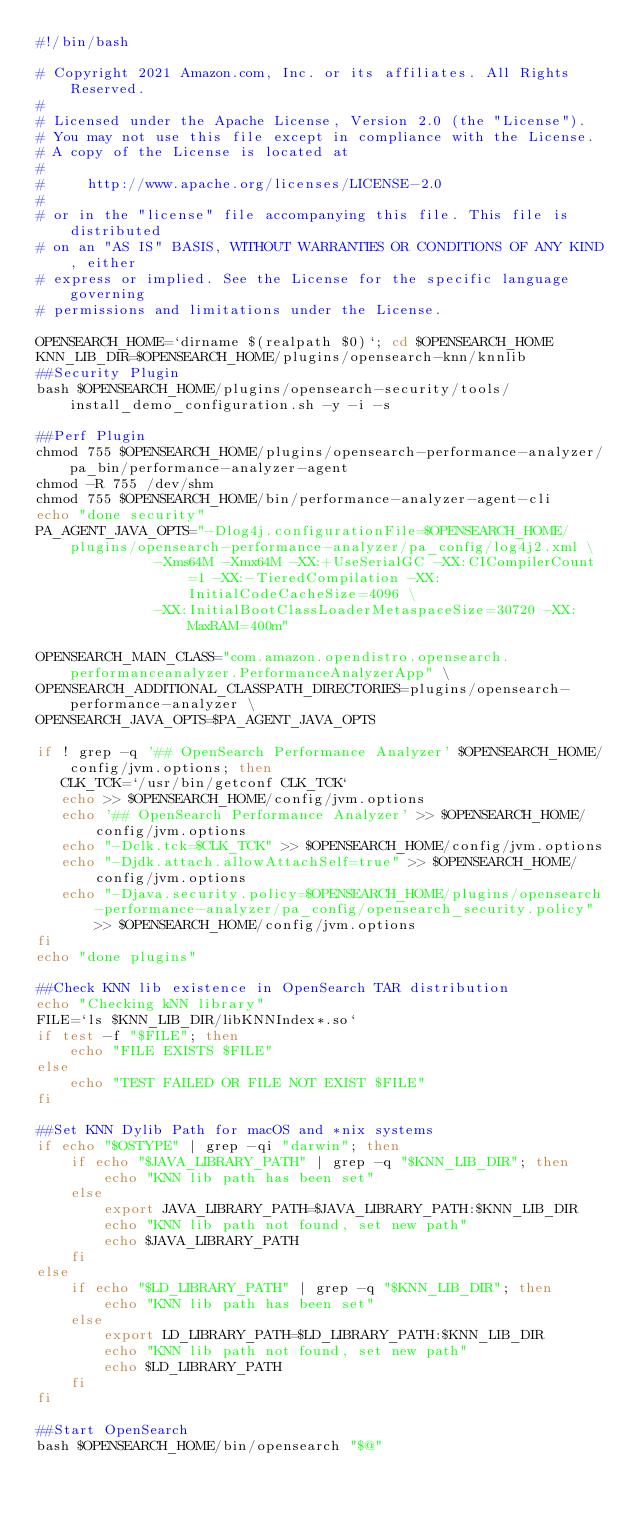<code> <loc_0><loc_0><loc_500><loc_500><_Bash_>#!/bin/bash

# Copyright 2021 Amazon.com, Inc. or its affiliates. All Rights Reserved.
#
# Licensed under the Apache License, Version 2.0 (the "License").
# You may not use this file except in compliance with the License.
# A copy of the License is located at
#
#     http://www.apache.org/licenses/LICENSE-2.0
#
# or in the "license" file accompanying this file. This file is distributed
# on an "AS IS" BASIS, WITHOUT WARRANTIES OR CONDITIONS OF ANY KIND, either
# express or implied. See the License for the specific language governing
# permissions and limitations under the License.

OPENSEARCH_HOME=`dirname $(realpath $0)`; cd $OPENSEARCH_HOME
KNN_LIB_DIR=$OPENSEARCH_HOME/plugins/opensearch-knn/knnlib
##Security Plugin
bash $OPENSEARCH_HOME/plugins/opensearch-security/tools/install_demo_configuration.sh -y -i -s

##Perf Plugin
chmod 755 $OPENSEARCH_HOME/plugins/opensearch-performance-analyzer/pa_bin/performance-analyzer-agent
chmod -R 755 /dev/shm
chmod 755 $OPENSEARCH_HOME/bin/performance-analyzer-agent-cli
echo "done security"
PA_AGENT_JAVA_OPTS="-Dlog4j.configurationFile=$OPENSEARCH_HOME/plugins/opensearch-performance-analyzer/pa_config/log4j2.xml \
              -Xms64M -Xmx64M -XX:+UseSerialGC -XX:CICompilerCount=1 -XX:-TieredCompilation -XX:InitialCodeCacheSize=4096 \
              -XX:InitialBootClassLoaderMetaspaceSize=30720 -XX:MaxRAM=400m"

OPENSEARCH_MAIN_CLASS="com.amazon.opendistro.opensearch.performanceanalyzer.PerformanceAnalyzerApp" \
OPENSEARCH_ADDITIONAL_CLASSPATH_DIRECTORIES=plugins/opensearch-performance-analyzer \
OPENSEARCH_JAVA_OPTS=$PA_AGENT_JAVA_OPTS

if ! grep -q '## OpenSearch Performance Analyzer' $OPENSEARCH_HOME/config/jvm.options; then
   CLK_TCK=`/usr/bin/getconf CLK_TCK`
   echo >> $OPENSEARCH_HOME/config/jvm.options
   echo '## OpenSearch Performance Analyzer' >> $OPENSEARCH_HOME/config/jvm.options
   echo "-Dclk.tck=$CLK_TCK" >> $OPENSEARCH_HOME/config/jvm.options
   echo "-Djdk.attach.allowAttachSelf=true" >> $OPENSEARCH_HOME/config/jvm.options
   echo "-Djava.security.policy=$OPENSEARCH_HOME/plugins/opensearch-performance-analyzer/pa_config/opensearch_security.policy" >> $OPENSEARCH_HOME/config/jvm.options
fi
echo "done plugins"

##Check KNN lib existence in OpenSearch TAR distribution
echo "Checking kNN library"
FILE=`ls $KNN_LIB_DIR/libKNNIndex*.so`
if test -f "$FILE"; then
    echo "FILE EXISTS $FILE"
else
    echo "TEST FAILED OR FILE NOT EXIST $FILE"
fi

##Set KNN Dylib Path for macOS and *nix systems
if echo "$OSTYPE" | grep -qi "darwin"; then
    if echo "$JAVA_LIBRARY_PATH" | grep -q "$KNN_LIB_DIR"; then
        echo "KNN lib path has been set"
    else
        export JAVA_LIBRARY_PATH=$JAVA_LIBRARY_PATH:$KNN_LIB_DIR
        echo "KNN lib path not found, set new path"
        echo $JAVA_LIBRARY_PATH
    fi
else
    if echo "$LD_LIBRARY_PATH" | grep -q "$KNN_LIB_DIR"; then
        echo "KNN lib path has been set"
    else
        export LD_LIBRARY_PATH=$LD_LIBRARY_PATH:$KNN_LIB_DIR
        echo "KNN lib path not found, set new path"
        echo $LD_LIBRARY_PATH
    fi
fi

##Start OpenSearch
bash $OPENSEARCH_HOME/bin/opensearch "$@"
</code> 